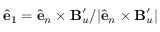Convert formula to latex. <formula><loc_0><loc_0><loc_500><loc_500>{ \hat { e } } _ { 1 } = { \hat { e } } _ { n } \times B _ { u } ^ { \prime } / | { \hat { e } } _ { n } \times B _ { u } ^ { \prime } |</formula> 